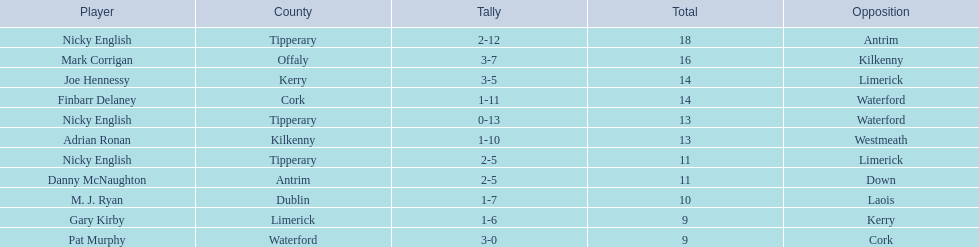I'm looking to parse the entire table for insights. Could you assist me with that? {'header': ['Player', 'County', 'Tally', 'Total', 'Opposition'], 'rows': [['Nicky English', 'Tipperary', '2-12', '18', 'Antrim'], ['Mark Corrigan', 'Offaly', '3-7', '16', 'Kilkenny'], ['Joe Hennessy', 'Kerry', '3-5', '14', 'Limerick'], ['Finbarr Delaney', 'Cork', '1-11', '14', 'Waterford'], ['Nicky English', 'Tipperary', '0-13', '13', 'Waterford'], ['Adrian Ronan', 'Kilkenny', '1-10', '13', 'Westmeath'], ['Nicky English', 'Tipperary', '2-5', '11', 'Limerick'], ['Danny McNaughton', 'Antrim', '2-5', '11', 'Down'], ['M. J. Ryan', 'Dublin', '1-7', '10', 'Laois'], ['Gary Kirby', 'Limerick', '1-6', '9', 'Kerry'], ['Pat Murphy', 'Waterford', '3-0', '9', 'Cork']]} What player got 10 total points in their game? M. J. Ryan. 